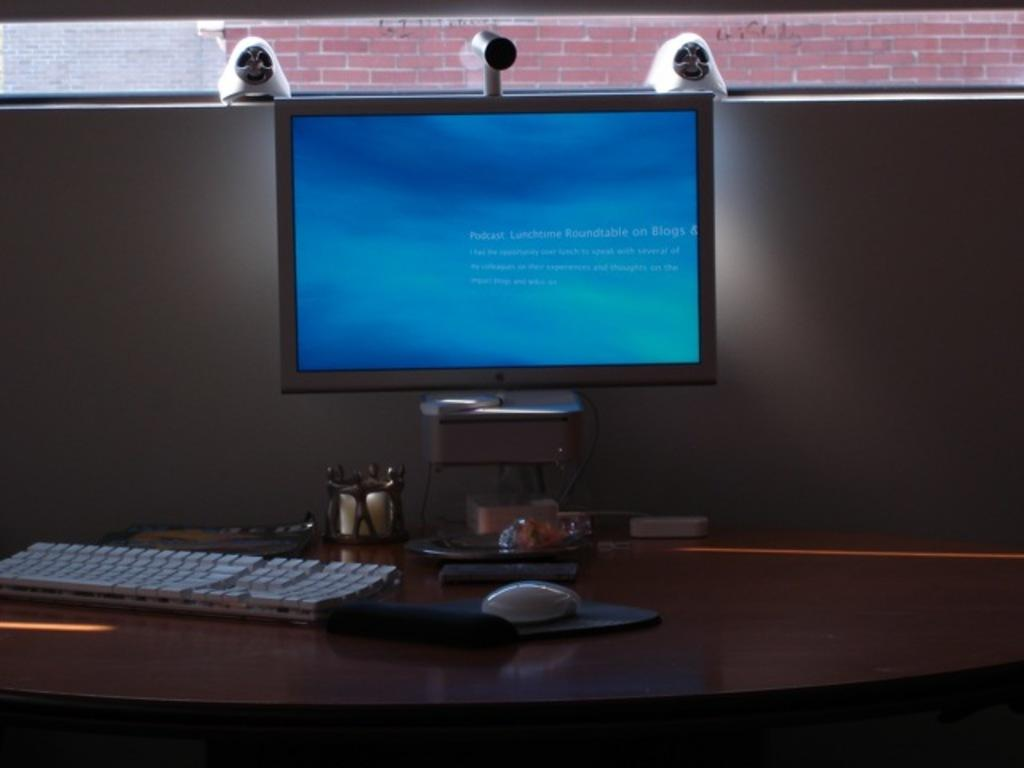What type of animal is on the table in the image? There is a mouse on the table in the image. What object is used to hold something on the table? There is a holder on the table. What type of reading material is on the table? There is a book on the table. What type of container is on the table? There is a box on the table. What type of electronic device is on the table? There is a monitor on the table. What type of input device is on the table? There is a keyboard on the table. What type of imaging device is on the table? There is a camera on the table. What can be seen in the background of the image? There is a brick wall in the background. What color is the sign on the table in the image? There is no sign present on the table in the image. What type of reaction can be seen from the mouse in the image? There is no reaction from the mouse in the image, as it is a still image. 